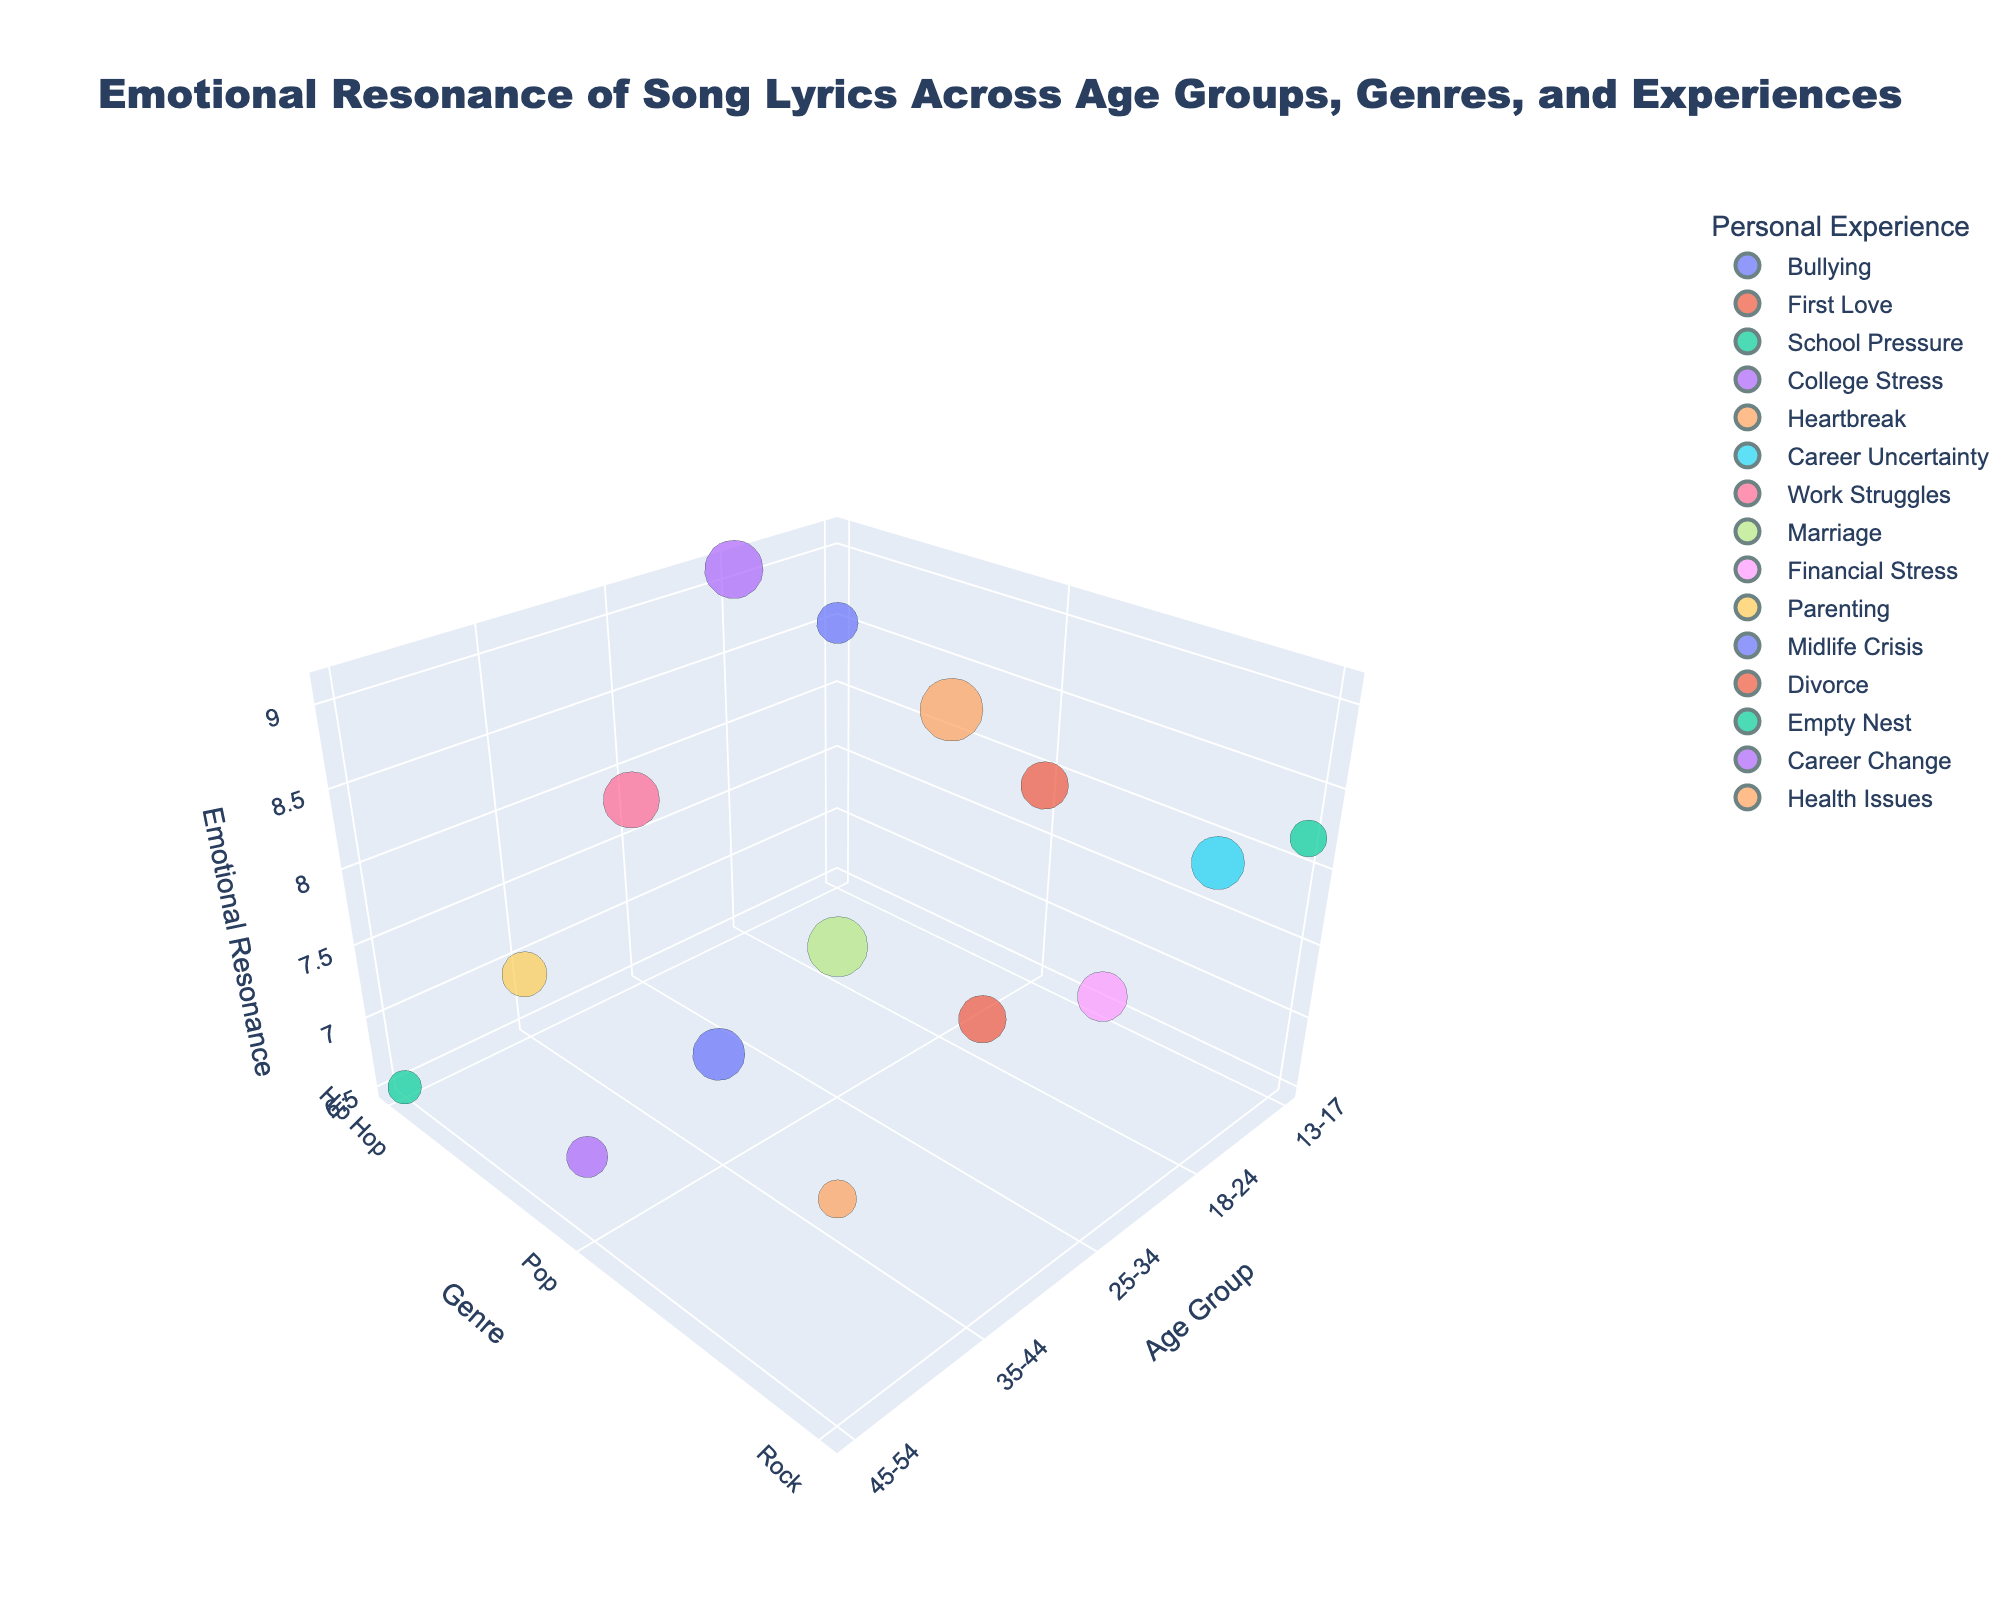What is the title of the 3D bubble chart? The title of the chart is typically located at the top, summarizing the overall content. In this case, it reads "Emotional Resonance of Song Lyrics Across Age Groups, Genres, and Experiences".
Answer: Emotional Resonance of Song Lyrics Across Age Groups, Genres, and Experiences Which age group has the highest emotional resonance for Hip Hop? By examining the y-axis labeled "Genre" for Hip Hop and  the x-axis labeled "Age Group", we see the "18-24" age group has the highest emotional resonance at 9.1.
Answer: 18-24 What age group and genre combination has the lowest listener count? Look at the size of the bubbles, which represent listener count. The smallest bubble corresponds to the "45-54" age group and Hip Hop genre.
Answer: 45-54, Hip Hop What personal experience under Rock genre resonates emotionally the most within the 35-44 age group? Find the "35-44" group on the x-axis and align it with the "Rock" genre on the y-axis. The corresponding bubble at the highest z-axis (Emotional Resonance) is "Divorce" with a resonance of 8.3.
Answer: Divorce Compare the emotional resonance of 'Heartbreak' in the 18-24 age group to 'Marriage' in the 25-34 age group. Which is higher? Locate the "Heartbreak" bubble in the "18-24" age group and "Pop" genre, which has an emotional resonance of 8.7. Then, find the "Marriage" bubble in the "25-34" age group and "Pop" genre with an emotional resonance of 7.5. Thus, "Heartbreak" has a higher emotional resonance.
Answer: Heartbreak What genre has the most consistently high emotional resonance across all age groups? By evaluating the bubbles' heights along the z-axis for each genre across the different age groups, "Rock" appears to have consistently high emotional resonance values.
Answer: Rock What is the average emotional resonance rating across the 25-34 age group? Sum the emotional resonance values for the 25-34 age group: (7.8 + 7.5 + 8.0) = 23.3. Then, divide by the number of ratings (3), resulting in an average of 7.77.
Answer: 7.77 Which age group has the broadest range of emotional resonance values for different personal experiences in the Rock genre? Examine the z-axis ranges for each age group's Rock genre bubbles. The "18-24" age group shows emotional resonance from 8.4 to 9.1, indicating a broader range compared to others, especially noticeable against narrow ranges like in age group "35-44."
Answer: 18-24 How does the listener count affect the size of the bubbles? The size of the bubbles is proportional to the listener count, with larger bubbles representing larger listener counts. For instance, the "Pop" genre for "18-24" age group has one of the largest bubbles, indicating the highest listener count.
Answer: Higher listener count results in larger bubbles Is there any genre that has a noticeable trend in emotional resonance as age increases? By following the z-axis values for each age group within a genre, "Hip Hop" shows a downward trend in emotional resonance as age increases. For example, it starts high at 9.1 for "18-24" and decreases to 6.5 for "45-54".
Answer: Hip Hop shows a downward trend 